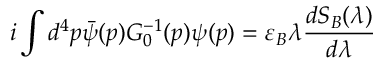<formula> <loc_0><loc_0><loc_500><loc_500>i \int d ^ { 4 } p \bar { \psi } ( p ) G _ { 0 } ^ { - 1 } ( p ) \psi ( p ) = \varepsilon _ { B } \lambda \frac { d S _ { B } ( \lambda ) } { d \lambda }</formula> 